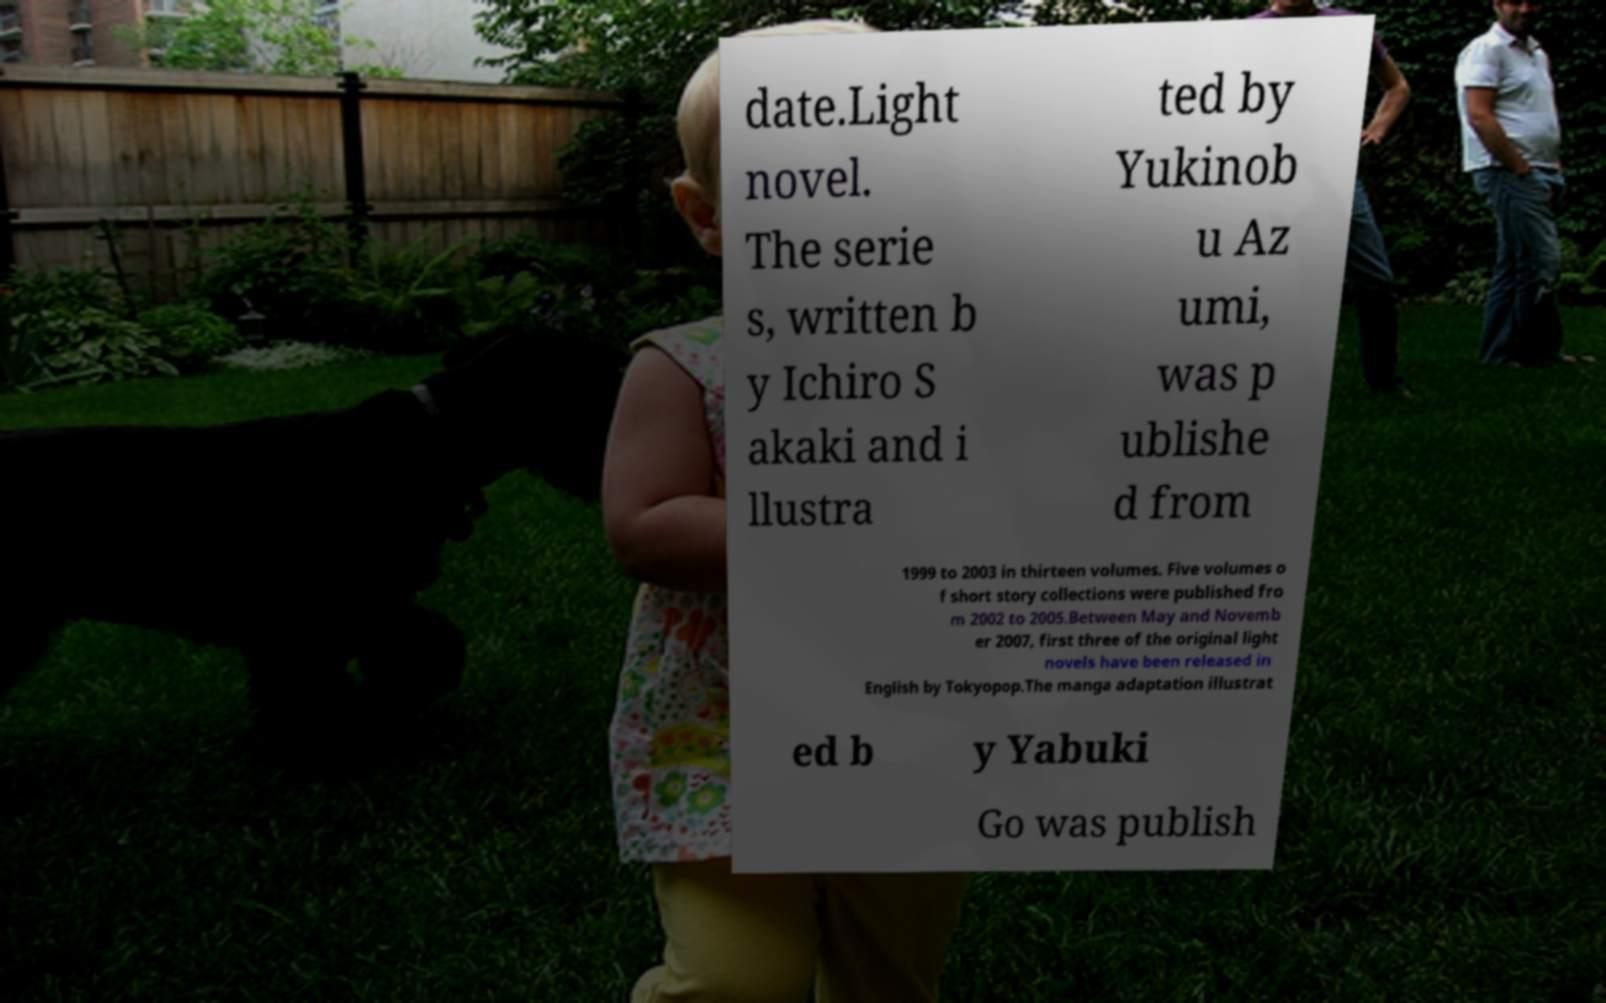Please read and relay the text visible in this image. What does it say? date.Light novel. The serie s, written b y Ichiro S akaki and i llustra ted by Yukinob u Az umi, was p ublishe d from 1999 to 2003 in thirteen volumes. Five volumes o f short story collections were published fro m 2002 to 2005.Between May and Novemb er 2007, first three of the original light novels have been released in English by Tokyopop.The manga adaptation illustrat ed b y Yabuki Go was publish 